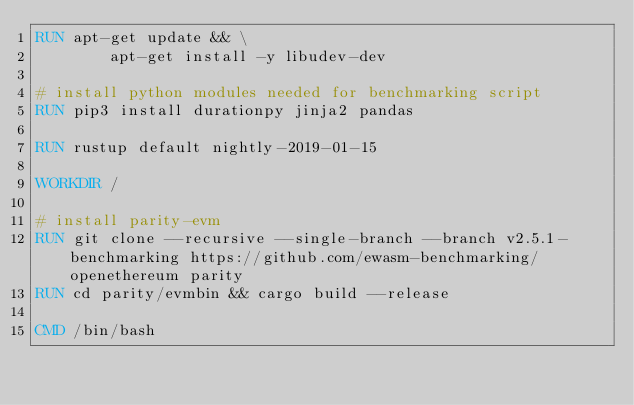<code> <loc_0><loc_0><loc_500><loc_500><_Dockerfile_>RUN apt-get update && \
        apt-get install -y libudev-dev

# install python modules needed for benchmarking script
RUN pip3 install durationpy jinja2 pandas

RUN rustup default nightly-2019-01-15

WORKDIR /

# install parity-evm
RUN git clone --recursive --single-branch --branch v2.5.1-benchmarking https://github.com/ewasm-benchmarking/openethereum parity
RUN cd parity/evmbin && cargo build --release

CMD /bin/bash
</code> 